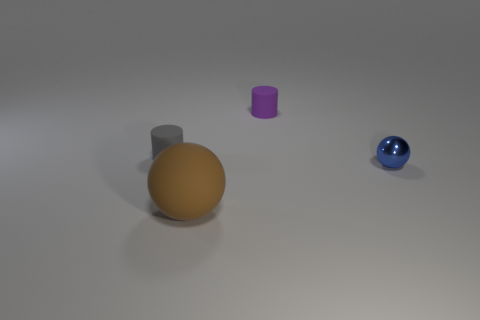Add 2 large brown objects. How many objects exist? 6 Subtract all tiny yellow shiny things. Subtract all large brown matte things. How many objects are left? 3 Add 2 small purple things. How many small purple things are left? 3 Add 4 small gray rubber things. How many small gray rubber things exist? 5 Subtract 0 yellow balls. How many objects are left? 4 